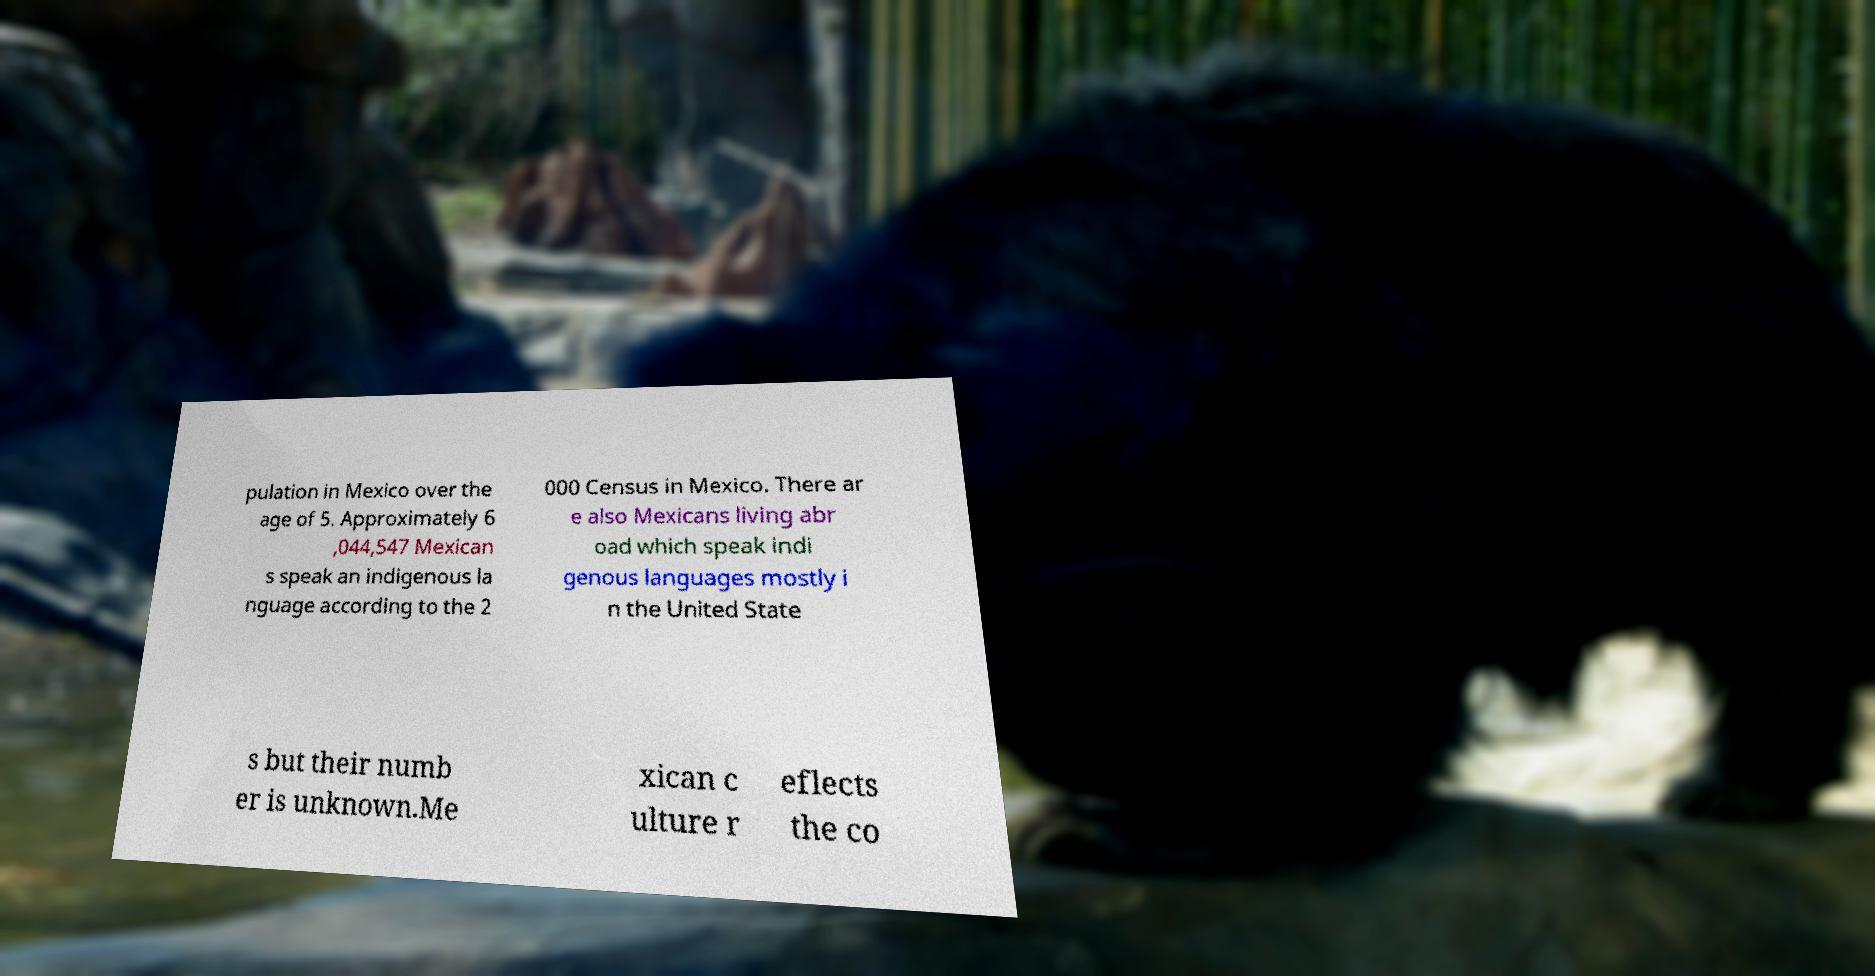Can you accurately transcribe the text from the provided image for me? pulation in Mexico over the age of 5. Approximately 6 ,044,547 Mexican s speak an indigenous la nguage according to the 2 000 Census in Mexico. There ar e also Mexicans living abr oad which speak indi genous languages mostly i n the United State s but their numb er is unknown.Me xican c ulture r eflects the co 